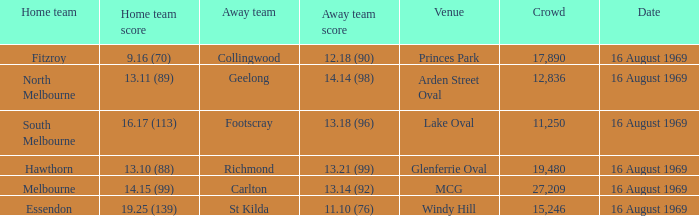What was the away team's score at Princes Park? 12.18 (90). 